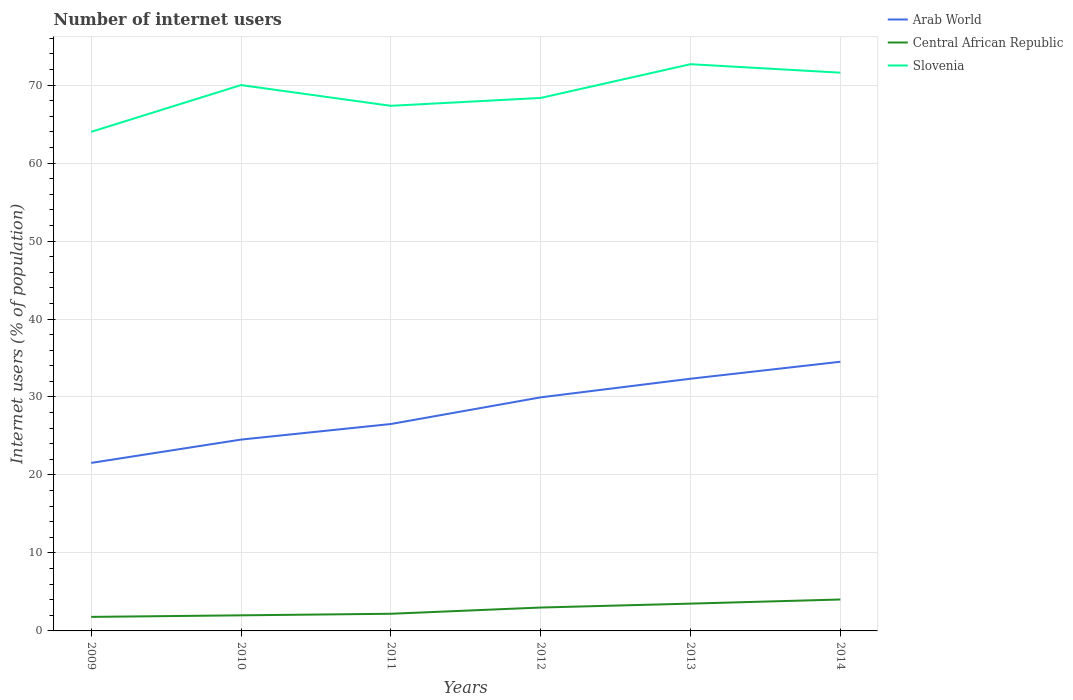In which year was the number of internet users in Central African Republic maximum?
Give a very brief answer. 2009. What is the total number of internet users in Slovenia in the graph?
Offer a very short reply. 1.09. What is the difference between the highest and the second highest number of internet users in Arab World?
Provide a succinct answer. 12.97. Is the number of internet users in Arab World strictly greater than the number of internet users in Slovenia over the years?
Make the answer very short. Yes. How many lines are there?
Provide a short and direct response. 3. How many years are there in the graph?
Provide a short and direct response. 6. What is the difference between two consecutive major ticks on the Y-axis?
Keep it short and to the point. 10. Does the graph contain any zero values?
Your answer should be very brief. No. Where does the legend appear in the graph?
Keep it short and to the point. Top right. How many legend labels are there?
Offer a very short reply. 3. What is the title of the graph?
Ensure brevity in your answer.  Number of internet users. Does "Switzerland" appear as one of the legend labels in the graph?
Ensure brevity in your answer.  No. What is the label or title of the Y-axis?
Your answer should be very brief. Internet users (% of population). What is the Internet users (% of population) in Arab World in 2009?
Offer a terse response. 21.55. What is the Internet users (% of population) of Central African Republic in 2009?
Make the answer very short. 1.8. What is the Internet users (% of population) in Slovenia in 2009?
Give a very brief answer. 64. What is the Internet users (% of population) in Arab World in 2010?
Your response must be concise. 24.54. What is the Internet users (% of population) in Arab World in 2011?
Your response must be concise. 26.53. What is the Internet users (% of population) of Central African Republic in 2011?
Provide a short and direct response. 2.2. What is the Internet users (% of population) in Slovenia in 2011?
Keep it short and to the point. 67.34. What is the Internet users (% of population) in Arab World in 2012?
Ensure brevity in your answer.  29.95. What is the Internet users (% of population) in Central African Republic in 2012?
Your answer should be compact. 3. What is the Internet users (% of population) in Slovenia in 2012?
Your answer should be very brief. 68.35. What is the Internet users (% of population) of Arab World in 2013?
Provide a short and direct response. 32.34. What is the Internet users (% of population) of Central African Republic in 2013?
Offer a terse response. 3.5. What is the Internet users (% of population) in Slovenia in 2013?
Ensure brevity in your answer.  72.68. What is the Internet users (% of population) of Arab World in 2014?
Your answer should be compact. 34.52. What is the Internet users (% of population) in Central African Republic in 2014?
Your response must be concise. 4.03. What is the Internet users (% of population) in Slovenia in 2014?
Keep it short and to the point. 71.59. Across all years, what is the maximum Internet users (% of population) of Arab World?
Your answer should be very brief. 34.52. Across all years, what is the maximum Internet users (% of population) of Central African Republic?
Ensure brevity in your answer.  4.03. Across all years, what is the maximum Internet users (% of population) in Slovenia?
Your answer should be compact. 72.68. Across all years, what is the minimum Internet users (% of population) of Arab World?
Give a very brief answer. 21.55. Across all years, what is the minimum Internet users (% of population) of Central African Republic?
Your answer should be compact. 1.8. What is the total Internet users (% of population) of Arab World in the graph?
Your response must be concise. 169.43. What is the total Internet users (% of population) of Central African Republic in the graph?
Provide a short and direct response. 16.53. What is the total Internet users (% of population) in Slovenia in the graph?
Your answer should be compact. 413.96. What is the difference between the Internet users (% of population) in Arab World in 2009 and that in 2010?
Your response must be concise. -2.99. What is the difference between the Internet users (% of population) in Central African Republic in 2009 and that in 2010?
Offer a very short reply. -0.2. What is the difference between the Internet users (% of population) in Arab World in 2009 and that in 2011?
Offer a terse response. -4.99. What is the difference between the Internet users (% of population) of Slovenia in 2009 and that in 2011?
Give a very brief answer. -3.34. What is the difference between the Internet users (% of population) of Arab World in 2009 and that in 2012?
Provide a short and direct response. -8.41. What is the difference between the Internet users (% of population) in Slovenia in 2009 and that in 2012?
Provide a short and direct response. -4.35. What is the difference between the Internet users (% of population) of Arab World in 2009 and that in 2013?
Make the answer very short. -10.8. What is the difference between the Internet users (% of population) in Central African Republic in 2009 and that in 2013?
Your answer should be very brief. -1.7. What is the difference between the Internet users (% of population) of Slovenia in 2009 and that in 2013?
Your answer should be very brief. -8.68. What is the difference between the Internet users (% of population) in Arab World in 2009 and that in 2014?
Provide a short and direct response. -12.97. What is the difference between the Internet users (% of population) of Central African Republic in 2009 and that in 2014?
Your response must be concise. -2.23. What is the difference between the Internet users (% of population) of Slovenia in 2009 and that in 2014?
Provide a succinct answer. -7.59. What is the difference between the Internet users (% of population) in Arab World in 2010 and that in 2011?
Keep it short and to the point. -2. What is the difference between the Internet users (% of population) in Slovenia in 2010 and that in 2011?
Provide a succinct answer. 2.66. What is the difference between the Internet users (% of population) in Arab World in 2010 and that in 2012?
Offer a very short reply. -5.42. What is the difference between the Internet users (% of population) of Slovenia in 2010 and that in 2012?
Keep it short and to the point. 1.65. What is the difference between the Internet users (% of population) of Arab World in 2010 and that in 2013?
Keep it short and to the point. -7.81. What is the difference between the Internet users (% of population) in Slovenia in 2010 and that in 2013?
Keep it short and to the point. -2.68. What is the difference between the Internet users (% of population) of Arab World in 2010 and that in 2014?
Your response must be concise. -9.98. What is the difference between the Internet users (% of population) of Central African Republic in 2010 and that in 2014?
Your answer should be compact. -2.03. What is the difference between the Internet users (% of population) in Slovenia in 2010 and that in 2014?
Your answer should be compact. -1.59. What is the difference between the Internet users (% of population) of Arab World in 2011 and that in 2012?
Ensure brevity in your answer.  -3.42. What is the difference between the Internet users (% of population) in Slovenia in 2011 and that in 2012?
Offer a terse response. -1.01. What is the difference between the Internet users (% of population) of Arab World in 2011 and that in 2013?
Your answer should be very brief. -5.81. What is the difference between the Internet users (% of population) in Slovenia in 2011 and that in 2013?
Give a very brief answer. -5.34. What is the difference between the Internet users (% of population) in Arab World in 2011 and that in 2014?
Offer a terse response. -7.98. What is the difference between the Internet users (% of population) of Central African Republic in 2011 and that in 2014?
Give a very brief answer. -1.83. What is the difference between the Internet users (% of population) in Slovenia in 2011 and that in 2014?
Keep it short and to the point. -4.25. What is the difference between the Internet users (% of population) of Arab World in 2012 and that in 2013?
Your answer should be compact. -2.39. What is the difference between the Internet users (% of population) of Slovenia in 2012 and that in 2013?
Offer a terse response. -4.33. What is the difference between the Internet users (% of population) in Arab World in 2012 and that in 2014?
Offer a very short reply. -4.56. What is the difference between the Internet users (% of population) in Central African Republic in 2012 and that in 2014?
Your response must be concise. -1.03. What is the difference between the Internet users (% of population) of Slovenia in 2012 and that in 2014?
Make the answer very short. -3.24. What is the difference between the Internet users (% of population) in Arab World in 2013 and that in 2014?
Offer a terse response. -2.18. What is the difference between the Internet users (% of population) of Central African Republic in 2013 and that in 2014?
Offer a very short reply. -0.53. What is the difference between the Internet users (% of population) of Slovenia in 2013 and that in 2014?
Ensure brevity in your answer.  1.09. What is the difference between the Internet users (% of population) in Arab World in 2009 and the Internet users (% of population) in Central African Republic in 2010?
Ensure brevity in your answer.  19.55. What is the difference between the Internet users (% of population) in Arab World in 2009 and the Internet users (% of population) in Slovenia in 2010?
Keep it short and to the point. -48.45. What is the difference between the Internet users (% of population) of Central African Republic in 2009 and the Internet users (% of population) of Slovenia in 2010?
Provide a short and direct response. -68.2. What is the difference between the Internet users (% of population) in Arab World in 2009 and the Internet users (% of population) in Central African Republic in 2011?
Offer a terse response. 19.35. What is the difference between the Internet users (% of population) in Arab World in 2009 and the Internet users (% of population) in Slovenia in 2011?
Offer a very short reply. -45.79. What is the difference between the Internet users (% of population) in Central African Republic in 2009 and the Internet users (% of population) in Slovenia in 2011?
Your answer should be compact. -65.54. What is the difference between the Internet users (% of population) of Arab World in 2009 and the Internet users (% of population) of Central African Republic in 2012?
Your answer should be very brief. 18.55. What is the difference between the Internet users (% of population) in Arab World in 2009 and the Internet users (% of population) in Slovenia in 2012?
Offer a very short reply. -46.8. What is the difference between the Internet users (% of population) of Central African Republic in 2009 and the Internet users (% of population) of Slovenia in 2012?
Ensure brevity in your answer.  -66.55. What is the difference between the Internet users (% of population) of Arab World in 2009 and the Internet users (% of population) of Central African Republic in 2013?
Your answer should be compact. 18.05. What is the difference between the Internet users (% of population) of Arab World in 2009 and the Internet users (% of population) of Slovenia in 2013?
Make the answer very short. -51.13. What is the difference between the Internet users (% of population) in Central African Republic in 2009 and the Internet users (% of population) in Slovenia in 2013?
Keep it short and to the point. -70.88. What is the difference between the Internet users (% of population) of Arab World in 2009 and the Internet users (% of population) of Central African Republic in 2014?
Your answer should be very brief. 17.52. What is the difference between the Internet users (% of population) of Arab World in 2009 and the Internet users (% of population) of Slovenia in 2014?
Ensure brevity in your answer.  -50.04. What is the difference between the Internet users (% of population) in Central African Republic in 2009 and the Internet users (% of population) in Slovenia in 2014?
Ensure brevity in your answer.  -69.79. What is the difference between the Internet users (% of population) in Arab World in 2010 and the Internet users (% of population) in Central African Republic in 2011?
Give a very brief answer. 22.34. What is the difference between the Internet users (% of population) in Arab World in 2010 and the Internet users (% of population) in Slovenia in 2011?
Provide a succinct answer. -42.8. What is the difference between the Internet users (% of population) in Central African Republic in 2010 and the Internet users (% of population) in Slovenia in 2011?
Offer a very short reply. -65.34. What is the difference between the Internet users (% of population) of Arab World in 2010 and the Internet users (% of population) of Central African Republic in 2012?
Make the answer very short. 21.54. What is the difference between the Internet users (% of population) in Arab World in 2010 and the Internet users (% of population) in Slovenia in 2012?
Ensure brevity in your answer.  -43.81. What is the difference between the Internet users (% of population) of Central African Republic in 2010 and the Internet users (% of population) of Slovenia in 2012?
Your answer should be compact. -66.35. What is the difference between the Internet users (% of population) in Arab World in 2010 and the Internet users (% of population) in Central African Republic in 2013?
Your answer should be very brief. 21.04. What is the difference between the Internet users (% of population) of Arab World in 2010 and the Internet users (% of population) of Slovenia in 2013?
Provide a short and direct response. -48.14. What is the difference between the Internet users (% of population) of Central African Republic in 2010 and the Internet users (% of population) of Slovenia in 2013?
Offer a terse response. -70.68. What is the difference between the Internet users (% of population) of Arab World in 2010 and the Internet users (% of population) of Central African Republic in 2014?
Ensure brevity in your answer.  20.51. What is the difference between the Internet users (% of population) of Arab World in 2010 and the Internet users (% of population) of Slovenia in 2014?
Make the answer very short. -47.05. What is the difference between the Internet users (% of population) in Central African Republic in 2010 and the Internet users (% of population) in Slovenia in 2014?
Your answer should be compact. -69.59. What is the difference between the Internet users (% of population) in Arab World in 2011 and the Internet users (% of population) in Central African Republic in 2012?
Provide a short and direct response. 23.53. What is the difference between the Internet users (% of population) in Arab World in 2011 and the Internet users (% of population) in Slovenia in 2012?
Make the answer very short. -41.82. What is the difference between the Internet users (% of population) in Central African Republic in 2011 and the Internet users (% of population) in Slovenia in 2012?
Your response must be concise. -66.15. What is the difference between the Internet users (% of population) of Arab World in 2011 and the Internet users (% of population) of Central African Republic in 2013?
Provide a succinct answer. 23.03. What is the difference between the Internet users (% of population) in Arab World in 2011 and the Internet users (% of population) in Slovenia in 2013?
Offer a very short reply. -46.14. What is the difference between the Internet users (% of population) of Central African Republic in 2011 and the Internet users (% of population) of Slovenia in 2013?
Make the answer very short. -70.48. What is the difference between the Internet users (% of population) of Arab World in 2011 and the Internet users (% of population) of Central African Republic in 2014?
Keep it short and to the point. 22.5. What is the difference between the Internet users (% of population) in Arab World in 2011 and the Internet users (% of population) in Slovenia in 2014?
Your answer should be very brief. -45.06. What is the difference between the Internet users (% of population) in Central African Republic in 2011 and the Internet users (% of population) in Slovenia in 2014?
Ensure brevity in your answer.  -69.39. What is the difference between the Internet users (% of population) of Arab World in 2012 and the Internet users (% of population) of Central African Republic in 2013?
Provide a succinct answer. 26.45. What is the difference between the Internet users (% of population) of Arab World in 2012 and the Internet users (% of population) of Slovenia in 2013?
Your response must be concise. -42.72. What is the difference between the Internet users (% of population) of Central African Republic in 2012 and the Internet users (% of population) of Slovenia in 2013?
Provide a succinct answer. -69.68. What is the difference between the Internet users (% of population) in Arab World in 2012 and the Internet users (% of population) in Central African Republic in 2014?
Your answer should be compact. 25.92. What is the difference between the Internet users (% of population) in Arab World in 2012 and the Internet users (% of population) in Slovenia in 2014?
Give a very brief answer. -41.64. What is the difference between the Internet users (% of population) in Central African Republic in 2012 and the Internet users (% of population) in Slovenia in 2014?
Your answer should be very brief. -68.59. What is the difference between the Internet users (% of population) in Arab World in 2013 and the Internet users (% of population) in Central African Republic in 2014?
Ensure brevity in your answer.  28.31. What is the difference between the Internet users (% of population) in Arab World in 2013 and the Internet users (% of population) in Slovenia in 2014?
Provide a succinct answer. -39.25. What is the difference between the Internet users (% of population) in Central African Republic in 2013 and the Internet users (% of population) in Slovenia in 2014?
Offer a terse response. -68.09. What is the average Internet users (% of population) of Arab World per year?
Offer a terse response. 28.24. What is the average Internet users (% of population) of Central African Republic per year?
Give a very brief answer. 2.75. What is the average Internet users (% of population) in Slovenia per year?
Make the answer very short. 68.99. In the year 2009, what is the difference between the Internet users (% of population) in Arab World and Internet users (% of population) in Central African Republic?
Offer a terse response. 19.75. In the year 2009, what is the difference between the Internet users (% of population) of Arab World and Internet users (% of population) of Slovenia?
Offer a very short reply. -42.45. In the year 2009, what is the difference between the Internet users (% of population) in Central African Republic and Internet users (% of population) in Slovenia?
Your answer should be compact. -62.2. In the year 2010, what is the difference between the Internet users (% of population) of Arab World and Internet users (% of population) of Central African Republic?
Give a very brief answer. 22.54. In the year 2010, what is the difference between the Internet users (% of population) of Arab World and Internet users (% of population) of Slovenia?
Provide a short and direct response. -45.46. In the year 2010, what is the difference between the Internet users (% of population) of Central African Republic and Internet users (% of population) of Slovenia?
Offer a terse response. -68. In the year 2011, what is the difference between the Internet users (% of population) in Arab World and Internet users (% of population) in Central African Republic?
Give a very brief answer. 24.33. In the year 2011, what is the difference between the Internet users (% of population) in Arab World and Internet users (% of population) in Slovenia?
Your answer should be compact. -40.81. In the year 2011, what is the difference between the Internet users (% of population) in Central African Republic and Internet users (% of population) in Slovenia?
Your answer should be compact. -65.14. In the year 2012, what is the difference between the Internet users (% of population) of Arab World and Internet users (% of population) of Central African Republic?
Keep it short and to the point. 26.95. In the year 2012, what is the difference between the Internet users (% of population) in Arab World and Internet users (% of population) in Slovenia?
Make the answer very short. -38.4. In the year 2012, what is the difference between the Internet users (% of population) in Central African Republic and Internet users (% of population) in Slovenia?
Provide a short and direct response. -65.35. In the year 2013, what is the difference between the Internet users (% of population) in Arab World and Internet users (% of population) in Central African Republic?
Give a very brief answer. 28.84. In the year 2013, what is the difference between the Internet users (% of population) in Arab World and Internet users (% of population) in Slovenia?
Give a very brief answer. -40.33. In the year 2013, what is the difference between the Internet users (% of population) in Central African Republic and Internet users (% of population) in Slovenia?
Keep it short and to the point. -69.18. In the year 2014, what is the difference between the Internet users (% of population) in Arab World and Internet users (% of population) in Central African Republic?
Keep it short and to the point. 30.49. In the year 2014, what is the difference between the Internet users (% of population) in Arab World and Internet users (% of population) in Slovenia?
Your answer should be very brief. -37.07. In the year 2014, what is the difference between the Internet users (% of population) of Central African Republic and Internet users (% of population) of Slovenia?
Ensure brevity in your answer.  -67.56. What is the ratio of the Internet users (% of population) in Arab World in 2009 to that in 2010?
Ensure brevity in your answer.  0.88. What is the ratio of the Internet users (% of population) in Central African Republic in 2009 to that in 2010?
Make the answer very short. 0.9. What is the ratio of the Internet users (% of population) of Slovenia in 2009 to that in 2010?
Ensure brevity in your answer.  0.91. What is the ratio of the Internet users (% of population) in Arab World in 2009 to that in 2011?
Your answer should be compact. 0.81. What is the ratio of the Internet users (% of population) of Central African Republic in 2009 to that in 2011?
Offer a very short reply. 0.82. What is the ratio of the Internet users (% of population) in Slovenia in 2009 to that in 2011?
Your answer should be very brief. 0.95. What is the ratio of the Internet users (% of population) in Arab World in 2009 to that in 2012?
Provide a succinct answer. 0.72. What is the ratio of the Internet users (% of population) of Central African Republic in 2009 to that in 2012?
Provide a succinct answer. 0.6. What is the ratio of the Internet users (% of population) of Slovenia in 2009 to that in 2012?
Your response must be concise. 0.94. What is the ratio of the Internet users (% of population) in Arab World in 2009 to that in 2013?
Your answer should be very brief. 0.67. What is the ratio of the Internet users (% of population) in Central African Republic in 2009 to that in 2013?
Offer a terse response. 0.51. What is the ratio of the Internet users (% of population) of Slovenia in 2009 to that in 2013?
Provide a short and direct response. 0.88. What is the ratio of the Internet users (% of population) of Arab World in 2009 to that in 2014?
Make the answer very short. 0.62. What is the ratio of the Internet users (% of population) of Central African Republic in 2009 to that in 2014?
Provide a succinct answer. 0.45. What is the ratio of the Internet users (% of population) in Slovenia in 2009 to that in 2014?
Provide a succinct answer. 0.89. What is the ratio of the Internet users (% of population) in Arab World in 2010 to that in 2011?
Your answer should be very brief. 0.92. What is the ratio of the Internet users (% of population) of Central African Republic in 2010 to that in 2011?
Give a very brief answer. 0.91. What is the ratio of the Internet users (% of population) of Slovenia in 2010 to that in 2011?
Offer a terse response. 1.04. What is the ratio of the Internet users (% of population) in Arab World in 2010 to that in 2012?
Your answer should be compact. 0.82. What is the ratio of the Internet users (% of population) of Central African Republic in 2010 to that in 2012?
Give a very brief answer. 0.67. What is the ratio of the Internet users (% of population) in Slovenia in 2010 to that in 2012?
Give a very brief answer. 1.02. What is the ratio of the Internet users (% of population) in Arab World in 2010 to that in 2013?
Provide a short and direct response. 0.76. What is the ratio of the Internet users (% of population) of Slovenia in 2010 to that in 2013?
Offer a terse response. 0.96. What is the ratio of the Internet users (% of population) of Arab World in 2010 to that in 2014?
Keep it short and to the point. 0.71. What is the ratio of the Internet users (% of population) in Central African Republic in 2010 to that in 2014?
Your answer should be compact. 0.5. What is the ratio of the Internet users (% of population) in Slovenia in 2010 to that in 2014?
Provide a succinct answer. 0.98. What is the ratio of the Internet users (% of population) of Arab World in 2011 to that in 2012?
Ensure brevity in your answer.  0.89. What is the ratio of the Internet users (% of population) of Central African Republic in 2011 to that in 2012?
Make the answer very short. 0.73. What is the ratio of the Internet users (% of population) in Slovenia in 2011 to that in 2012?
Give a very brief answer. 0.99. What is the ratio of the Internet users (% of population) in Arab World in 2011 to that in 2013?
Offer a terse response. 0.82. What is the ratio of the Internet users (% of population) in Central African Republic in 2011 to that in 2013?
Your answer should be very brief. 0.63. What is the ratio of the Internet users (% of population) of Slovenia in 2011 to that in 2013?
Keep it short and to the point. 0.93. What is the ratio of the Internet users (% of population) in Arab World in 2011 to that in 2014?
Make the answer very short. 0.77. What is the ratio of the Internet users (% of population) in Central African Republic in 2011 to that in 2014?
Give a very brief answer. 0.55. What is the ratio of the Internet users (% of population) of Slovenia in 2011 to that in 2014?
Give a very brief answer. 0.94. What is the ratio of the Internet users (% of population) in Arab World in 2012 to that in 2013?
Your response must be concise. 0.93. What is the ratio of the Internet users (% of population) in Central African Republic in 2012 to that in 2013?
Make the answer very short. 0.86. What is the ratio of the Internet users (% of population) in Slovenia in 2012 to that in 2013?
Provide a succinct answer. 0.94. What is the ratio of the Internet users (% of population) in Arab World in 2012 to that in 2014?
Give a very brief answer. 0.87. What is the ratio of the Internet users (% of population) in Central African Republic in 2012 to that in 2014?
Offer a terse response. 0.74. What is the ratio of the Internet users (% of population) in Slovenia in 2012 to that in 2014?
Give a very brief answer. 0.95. What is the ratio of the Internet users (% of population) of Arab World in 2013 to that in 2014?
Keep it short and to the point. 0.94. What is the ratio of the Internet users (% of population) in Central African Republic in 2013 to that in 2014?
Your answer should be very brief. 0.87. What is the ratio of the Internet users (% of population) in Slovenia in 2013 to that in 2014?
Keep it short and to the point. 1.02. What is the difference between the highest and the second highest Internet users (% of population) in Arab World?
Give a very brief answer. 2.18. What is the difference between the highest and the second highest Internet users (% of population) in Central African Republic?
Offer a terse response. 0.53. What is the difference between the highest and the second highest Internet users (% of population) of Slovenia?
Your answer should be compact. 1.09. What is the difference between the highest and the lowest Internet users (% of population) of Arab World?
Keep it short and to the point. 12.97. What is the difference between the highest and the lowest Internet users (% of population) of Central African Republic?
Offer a terse response. 2.23. What is the difference between the highest and the lowest Internet users (% of population) in Slovenia?
Ensure brevity in your answer.  8.68. 